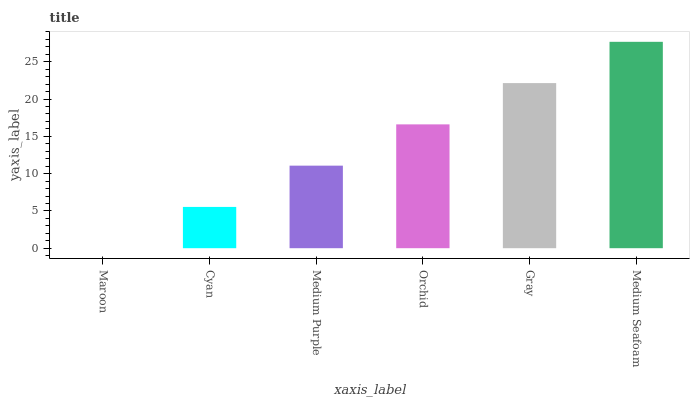Is Maroon the minimum?
Answer yes or no. Yes. Is Medium Seafoam the maximum?
Answer yes or no. Yes. Is Cyan the minimum?
Answer yes or no. No. Is Cyan the maximum?
Answer yes or no. No. Is Cyan greater than Maroon?
Answer yes or no. Yes. Is Maroon less than Cyan?
Answer yes or no. Yes. Is Maroon greater than Cyan?
Answer yes or no. No. Is Cyan less than Maroon?
Answer yes or no. No. Is Orchid the high median?
Answer yes or no. Yes. Is Medium Purple the low median?
Answer yes or no. Yes. Is Medium Seafoam the high median?
Answer yes or no. No. Is Maroon the low median?
Answer yes or no. No. 